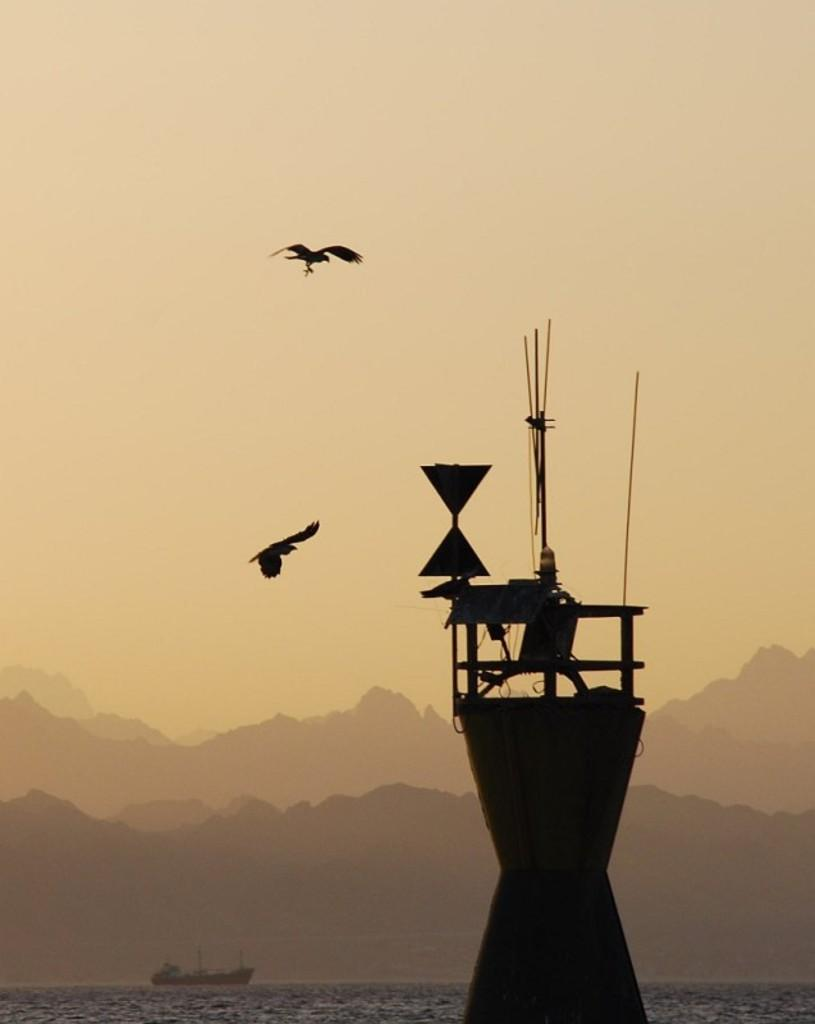What structure is the main focus of the image? There is a tower in the image. What can be seen floating on the water in the image? There is a boat floating on the water in the image. What type of landscape feature is present at the bottom of the image? There are hills at the bottom of the image. What type of animals can be seen in the sky in the image? There are birds in the sky in the image. What type of parent is taking care of the rabbit in the image? There is no rabbit or parent present in the image. What type of sail is attached to the boat in the image? There is no sail visible in the image; only a boat floating on the water is present. 